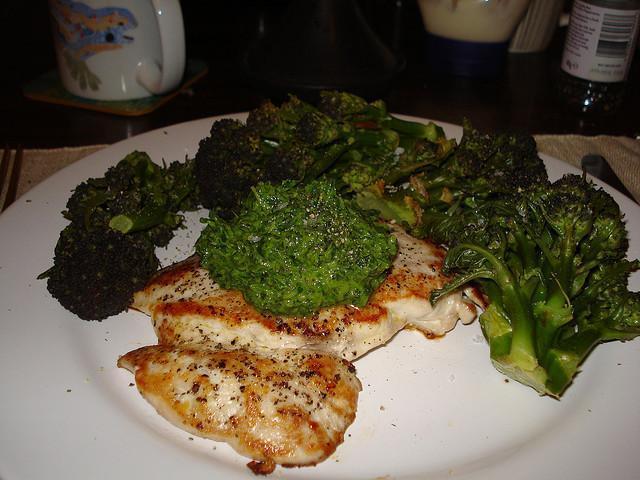How many different vegetables are on the plate?
Give a very brief answer. 1. How many plates are there?
Give a very brief answer. 1. How many tacos are on the plate?
Give a very brief answer. 0. How many pickles are there?
Give a very brief answer. 0. How many dining tables can be seen?
Give a very brief answer. 2. How many broccolis can you see?
Give a very brief answer. 7. 